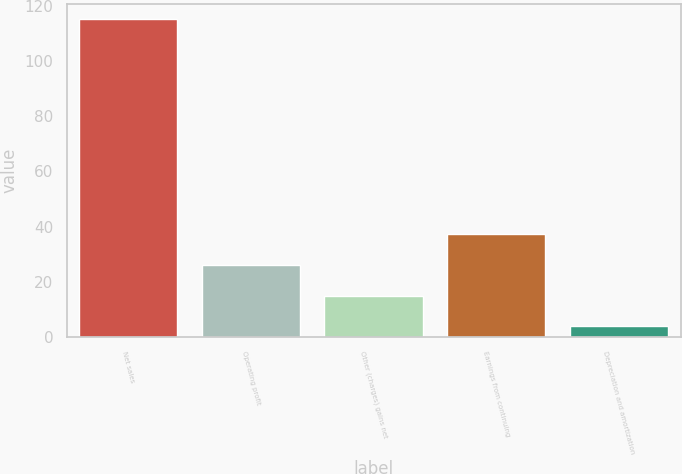Convert chart to OTSL. <chart><loc_0><loc_0><loc_500><loc_500><bar_chart><fcel>Net sales<fcel>Operating profit<fcel>Other (charges) gains net<fcel>Earnings from continuing<fcel>Depreciation and amortization<nl><fcel>115<fcel>26.2<fcel>15.1<fcel>37.3<fcel>4<nl></chart> 